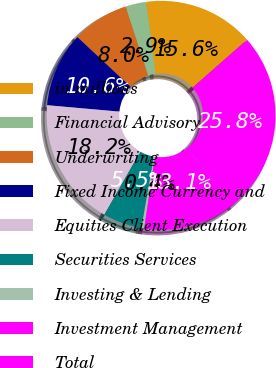Convert chart to OTSL. <chart><loc_0><loc_0><loc_500><loc_500><pie_chart><fcel>in millions<fcel>Financial Advisory<fcel>Underwriting<fcel>Fixed Income Currency and<fcel>Equities Client Execution<fcel>Securities Services<fcel>Investing & Lending<fcel>Investment Management<fcel>Total<nl><fcel>15.62%<fcel>2.94%<fcel>8.01%<fcel>10.55%<fcel>18.15%<fcel>5.48%<fcel>0.41%<fcel>13.08%<fcel>25.75%<nl></chart> 